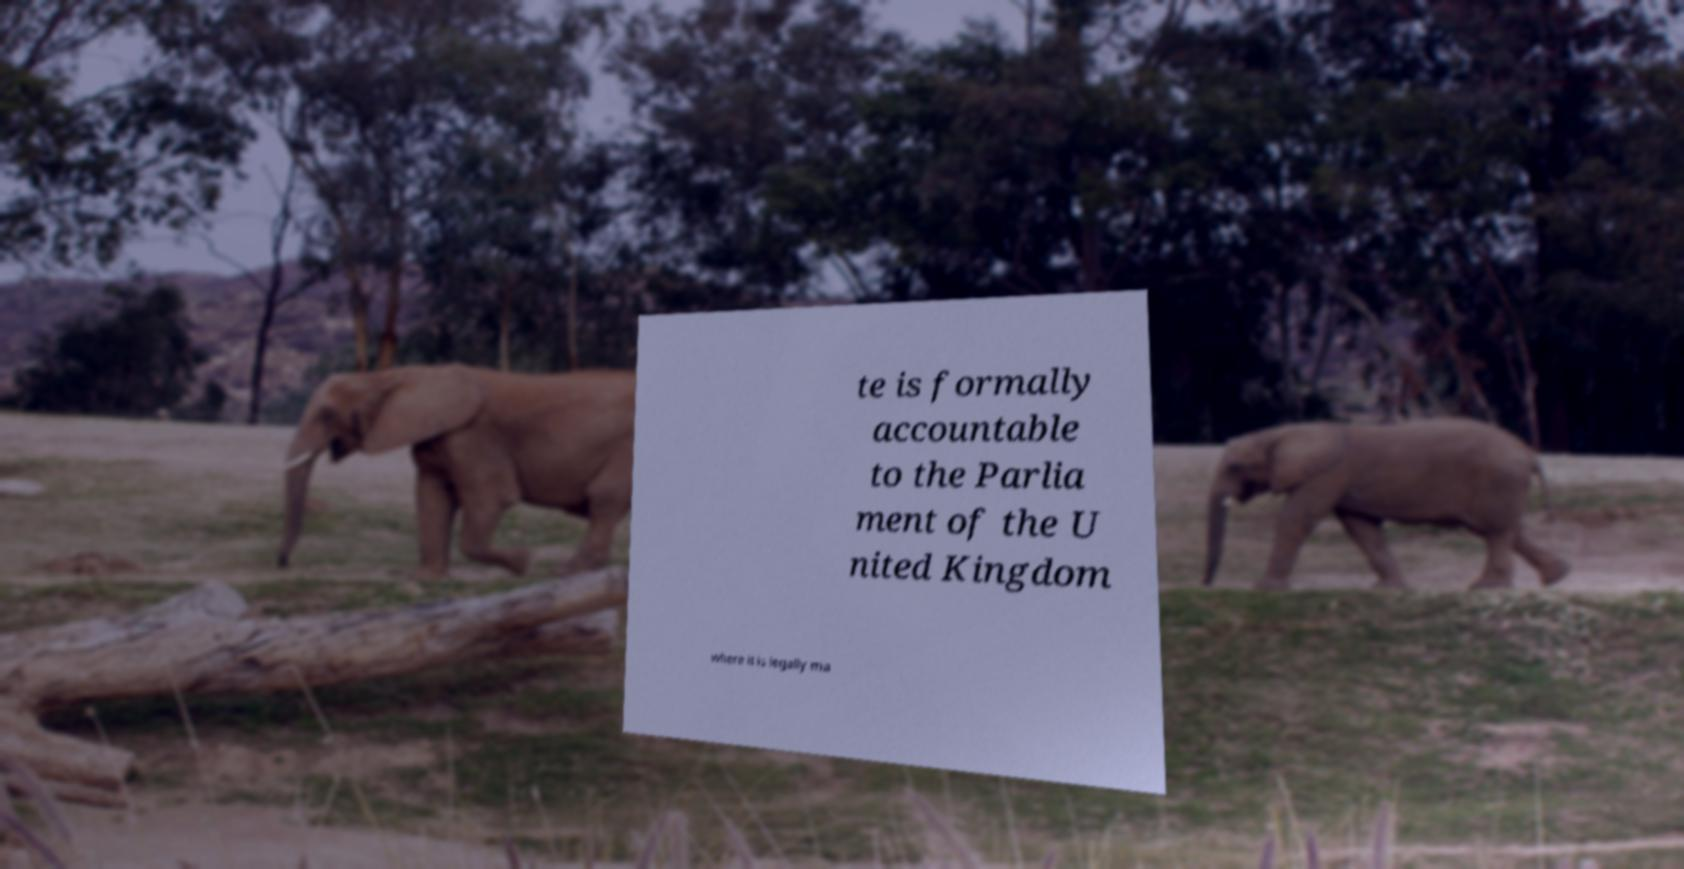Can you accurately transcribe the text from the provided image for me? te is formally accountable to the Parlia ment of the U nited Kingdom where it is legally ma 